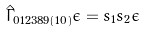<formula> <loc_0><loc_0><loc_500><loc_500>\hat { \Gamma } _ { 0 1 2 3 8 9 ( 1 0 ) } \epsilon = s _ { 1 } s _ { 2 } \epsilon</formula> 